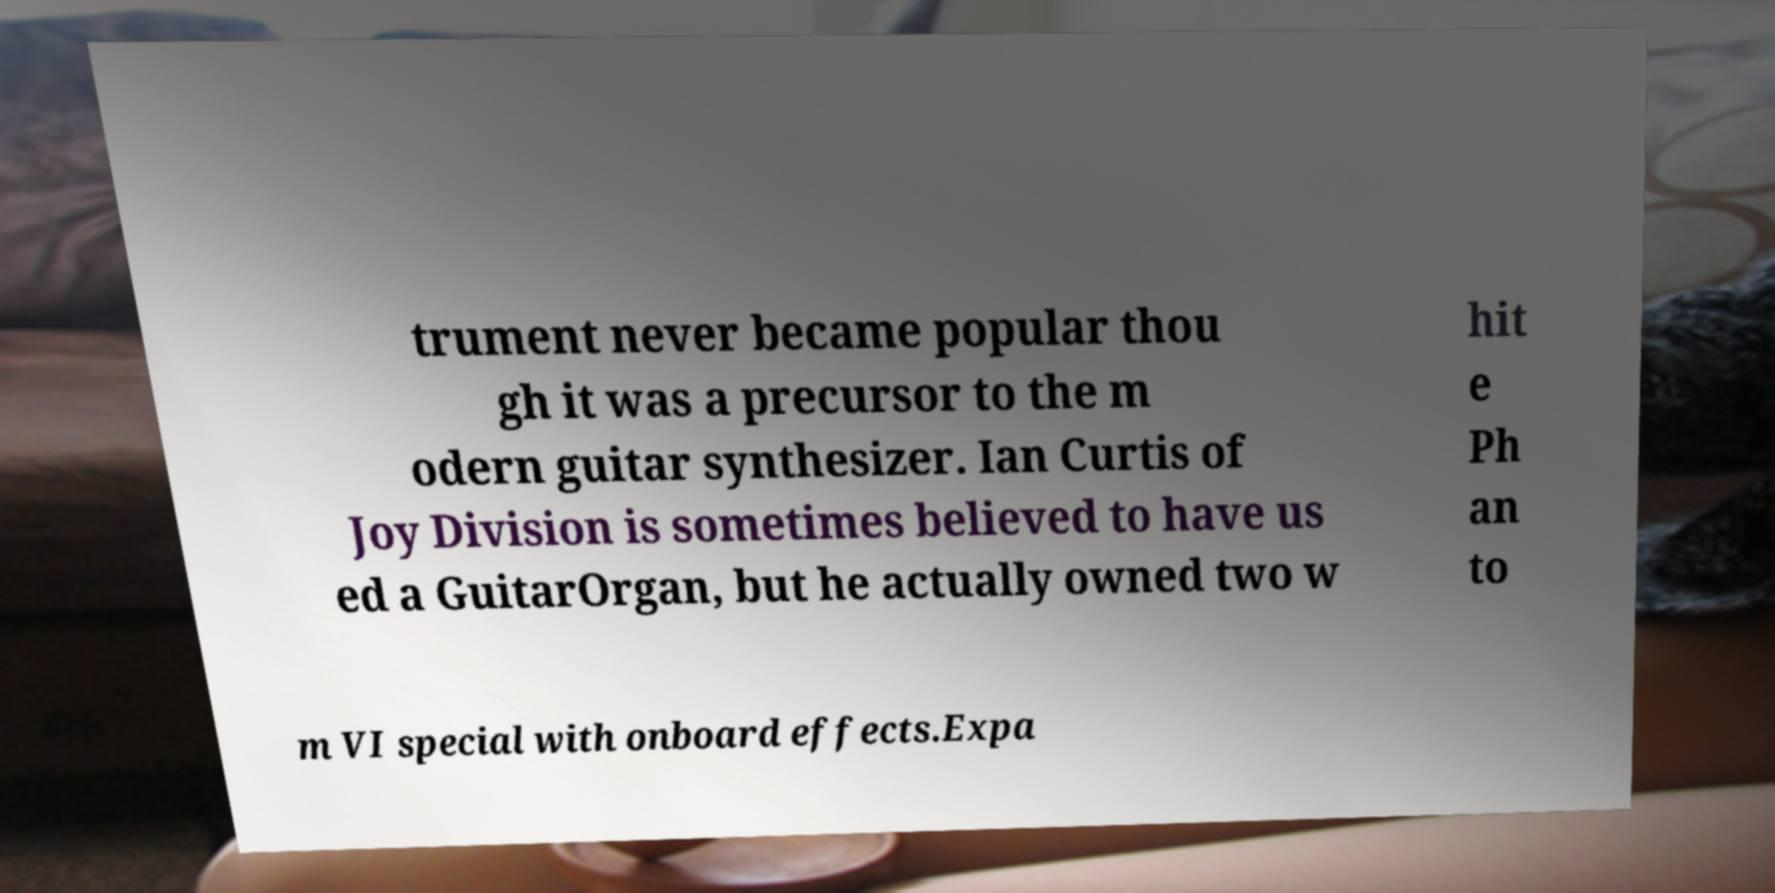I need the written content from this picture converted into text. Can you do that? trument never became popular thou gh it was a precursor to the m odern guitar synthesizer. Ian Curtis of Joy Division is sometimes believed to have us ed a GuitarOrgan, but he actually owned two w hit e Ph an to m VI special with onboard effects.Expa 